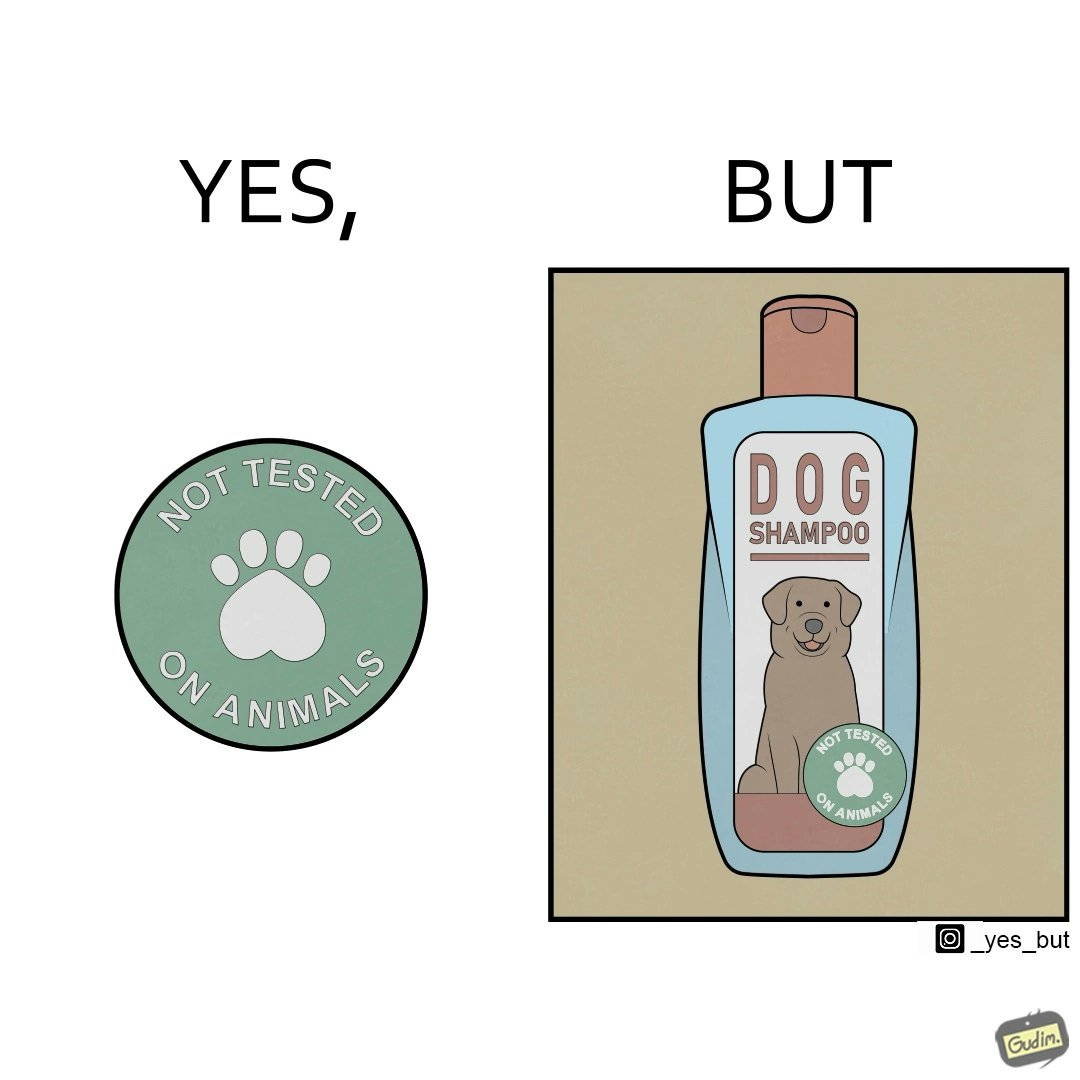What is the satirical meaning behind this image? The images are ironic since a dog shampoo bottle has a sticker indicating that it has not been tested on animals and hence might not be safe for animal use. It is amusing that a product designed to be used by animals is not tested on animals for their safety 